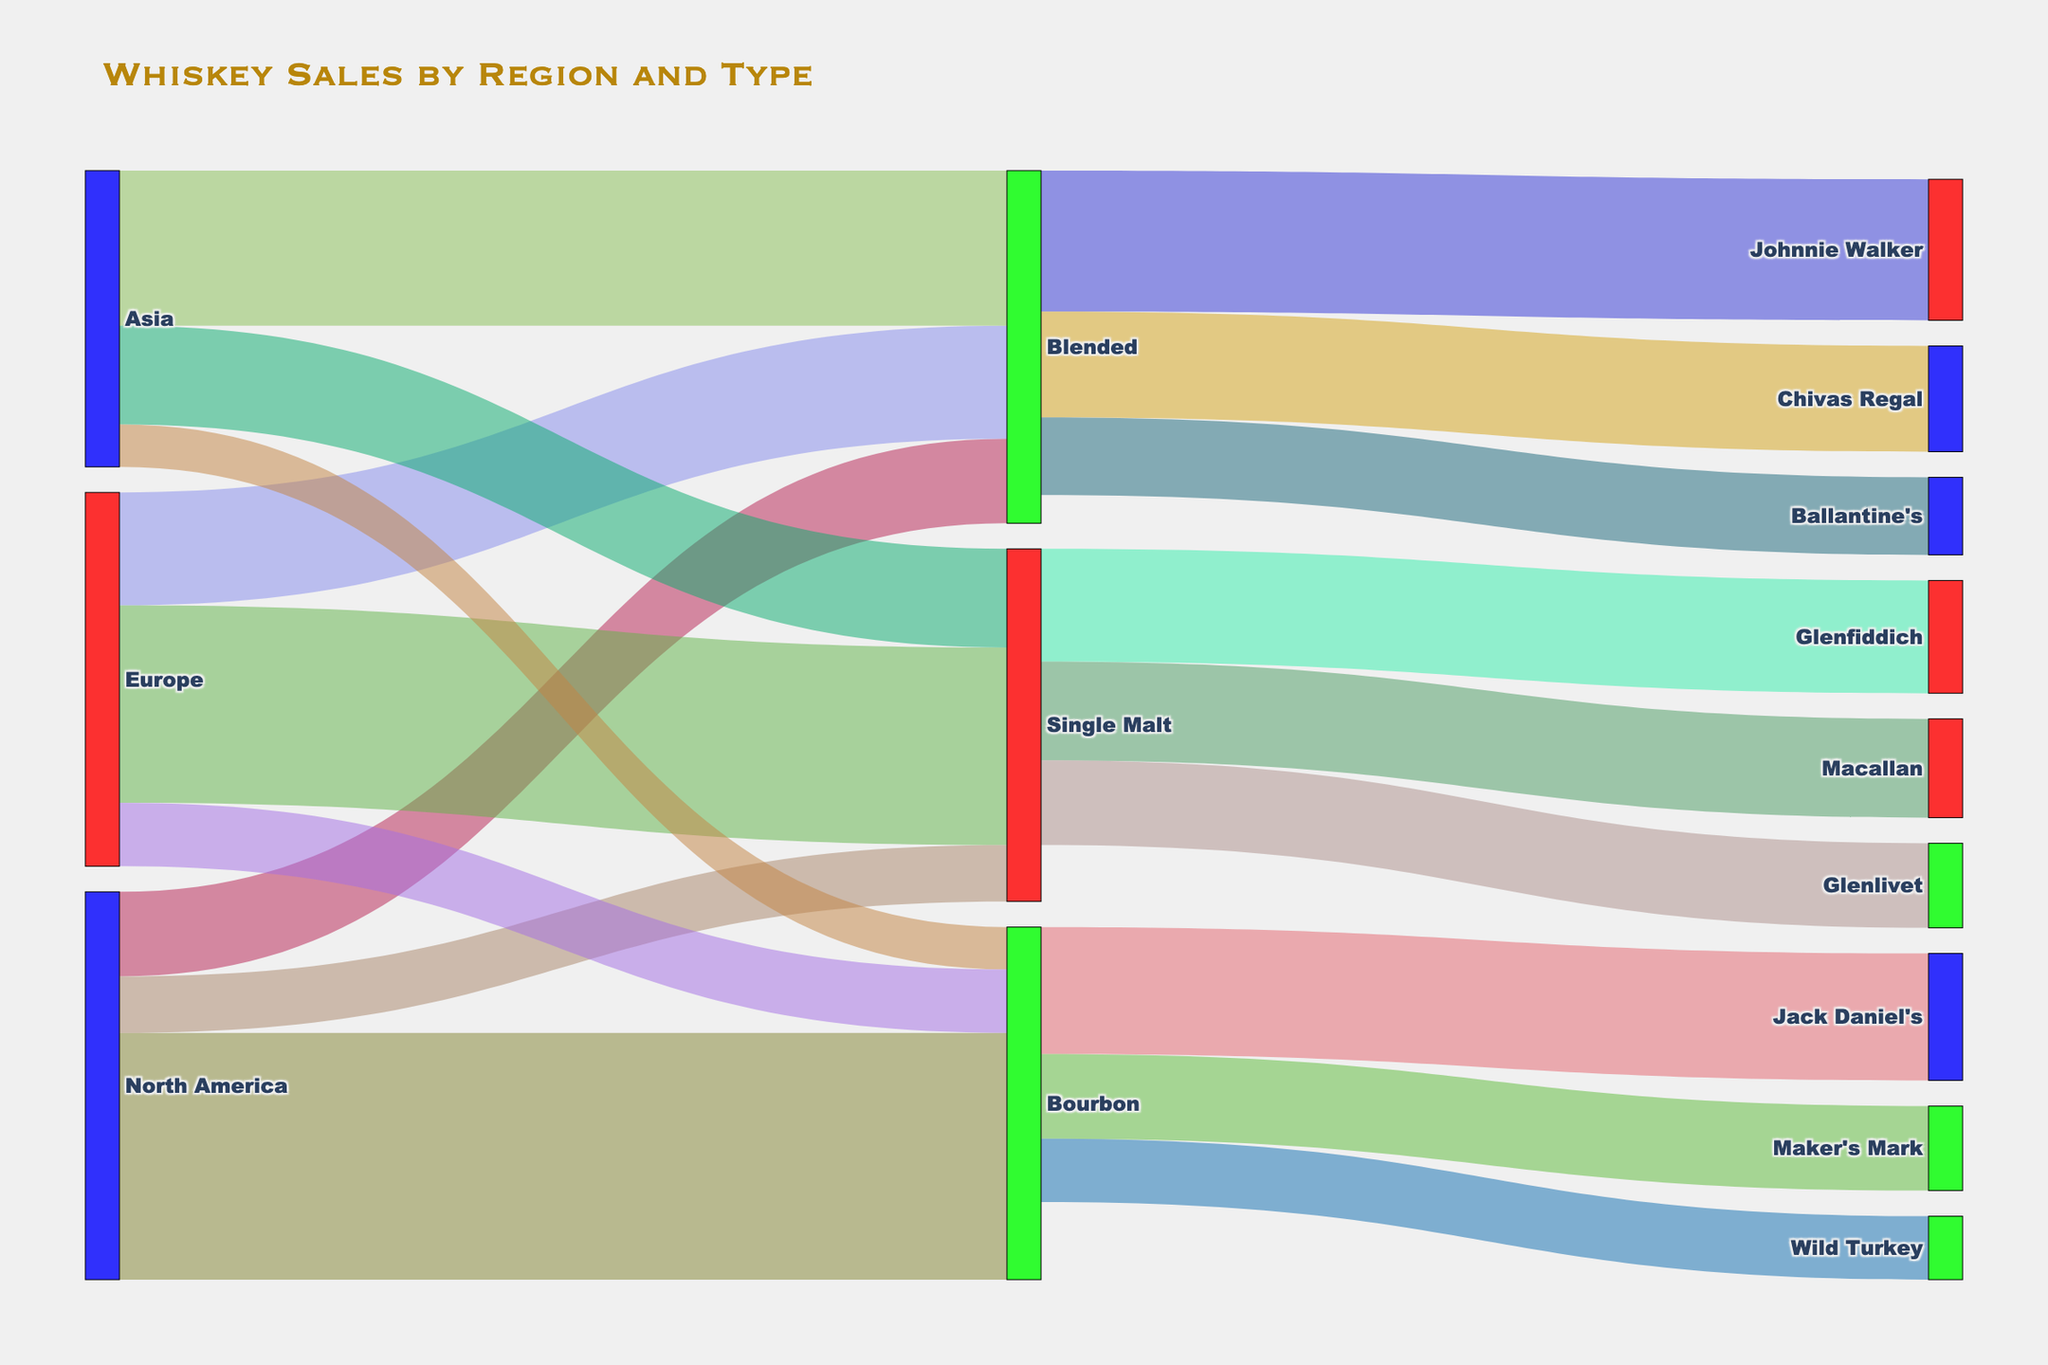What is the title of the figure? The title of the figure is displayed prominently at the top in a larger, bold font.
Answer: Whiskey Sales by Region and Type How many unique regions are represented in this diagram? The regions are the first layer of nodes in the Sankey Diagram and are connected directly to the whiskey types. There are three unique regions.
Answer: 3 What is the total amount of whiskey sold in North America? To find the total amount of whiskey sold in North America, add up the values for Bourbon, Blended, and Single Malt in North America: 3500 (Bourbon) + 1200 (Blended) + 800 (Single Malt).
Answer: 5500 Which type of whiskey has the highest sales in Asia? Look at the links emanating from Asia to different whiskey types (Blended, Single Malt, Bourbon) and compare the values. The highest value is linked to Blended.
Answer: Blended Which brand of Bourbon has the highest sales? Follow the links from Bourbon to different brands (Jack Daniel's, Maker's Mark, Wild Turkey) and compare their values. The highest value is linked to Jack Daniel's.
Answer: Jack Daniel's What is the combined sales value of all Single Malt whiskeys? Sum the sales values of Single Malt whiskeys across all regions: 800 (North America) + 2800 (Europe) + 1400 (Asia).
Answer: 5000 How do the sales of Blended whiskey in Europe compare to those in Asia? Compare the links from Europe to Blended and Asia to Blended. Europe has 1600 and Asia has 2200.
Answer: Europe is less than Asia Which region has the lowest sales of Bourbon whiskey? Compare the links to Bourbon from all regions (North America, Europe, Asia). Asia has the lowest value.
Answer: Asia What is the total sales for the brand Johnnie Walker? Follow the link from Blended to Johnnie Walker and read the value.
Answer: 2000 Which regions sell Glenlivet Single Malt whiskey, and what are the values? Glenlivet is connected only to Single Malt, so trace back from Single Malt to regions. Glenlivet is sold in Europe (2800) and Asia (1400).
Answer: Europe: 2800, Asia: 1400 